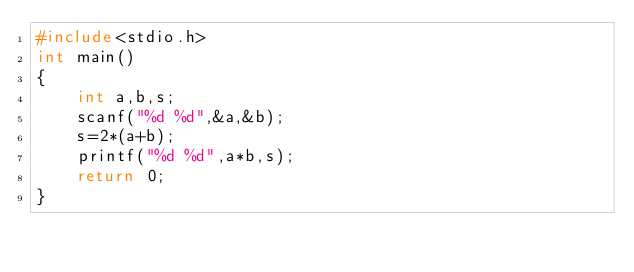Convert code to text. <code><loc_0><loc_0><loc_500><loc_500><_C_>#include<stdio.h>
int main()
{
    int a,b,s;
    scanf("%d %d",&a,&b);
    s=2*(a+b);
    printf("%d %d",a*b,s);
    return 0;
}
</code> 